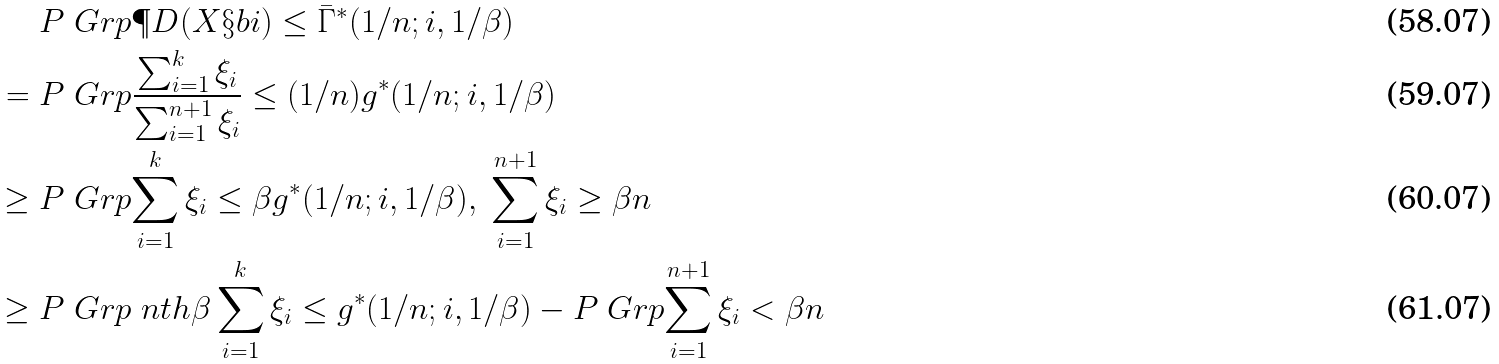<formula> <loc_0><loc_0><loc_500><loc_500>& P \ G r p { \P D ( X \S b i ) \leq \bar { \Gamma } ^ { * } ( 1 / n ; i , 1 / \beta ) } \\ = \ & P \ G r p { \frac { \sum _ { i = 1 } ^ { k } \xi _ { i } } { \sum _ { i = 1 } ^ { n + 1 } \xi _ { i } } \leq ( 1 / n ) g ^ { * } ( 1 / n ; i , 1 / \beta ) } \\ \geq \ & P \ G r p { \sum _ { i = 1 } ^ { k } \xi _ { i } \leq \beta g ^ { * } ( 1 / n ; i , 1 / \beta ) , \ \sum _ { i = 1 } ^ { n + 1 } \xi _ { i } \geq \beta n } \\ \geq \ & P \ G r p { \ n t h \beta \sum _ { i = 1 } ^ { k } \xi _ { i } \leq g ^ { * } ( 1 / n ; i , 1 / \beta ) } - P \ G r p { \sum _ { i = 1 } ^ { n + 1 } \xi _ { i } < \beta n }</formula> 